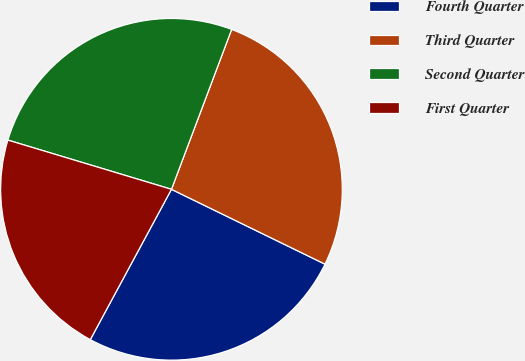Convert chart. <chart><loc_0><loc_0><loc_500><loc_500><pie_chart><fcel>Fourth Quarter<fcel>Third Quarter<fcel>Second Quarter<fcel>First Quarter<nl><fcel>25.66%<fcel>26.49%<fcel>26.08%<fcel>21.77%<nl></chart> 